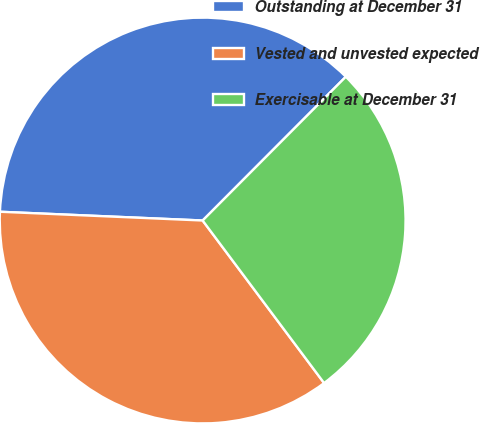Convert chart to OTSL. <chart><loc_0><loc_0><loc_500><loc_500><pie_chart><fcel>Outstanding at December 31<fcel>Vested and unvested expected<fcel>Exercisable at December 31<nl><fcel>36.78%<fcel>35.9%<fcel>27.32%<nl></chart> 